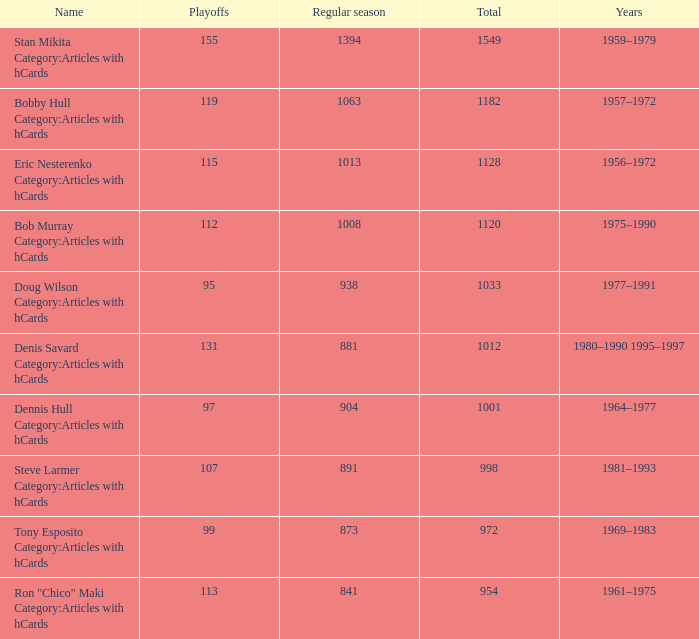How may times is regular season 1063 and playoffs more than 119? 0.0. 